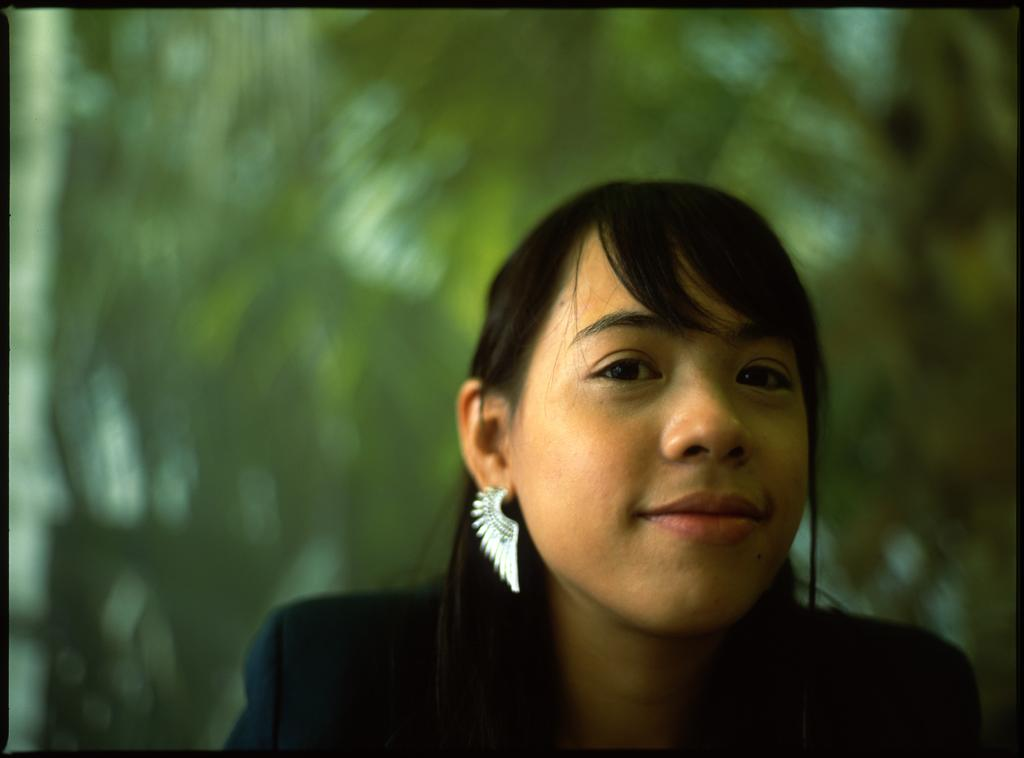Who is present in the image? There is a lady in the image. What is the lady wearing in the image? The lady is wearing earrings in the image. What is the lady's facial expression in the image? The lady is smiling in the image. Can you describe the background of the image? There is a green color blur image in the background of the image. What type of dog is walking on the sidewalk in the image? There is no dog or sidewalk present in the image; it features a lady with a green color blur background. 